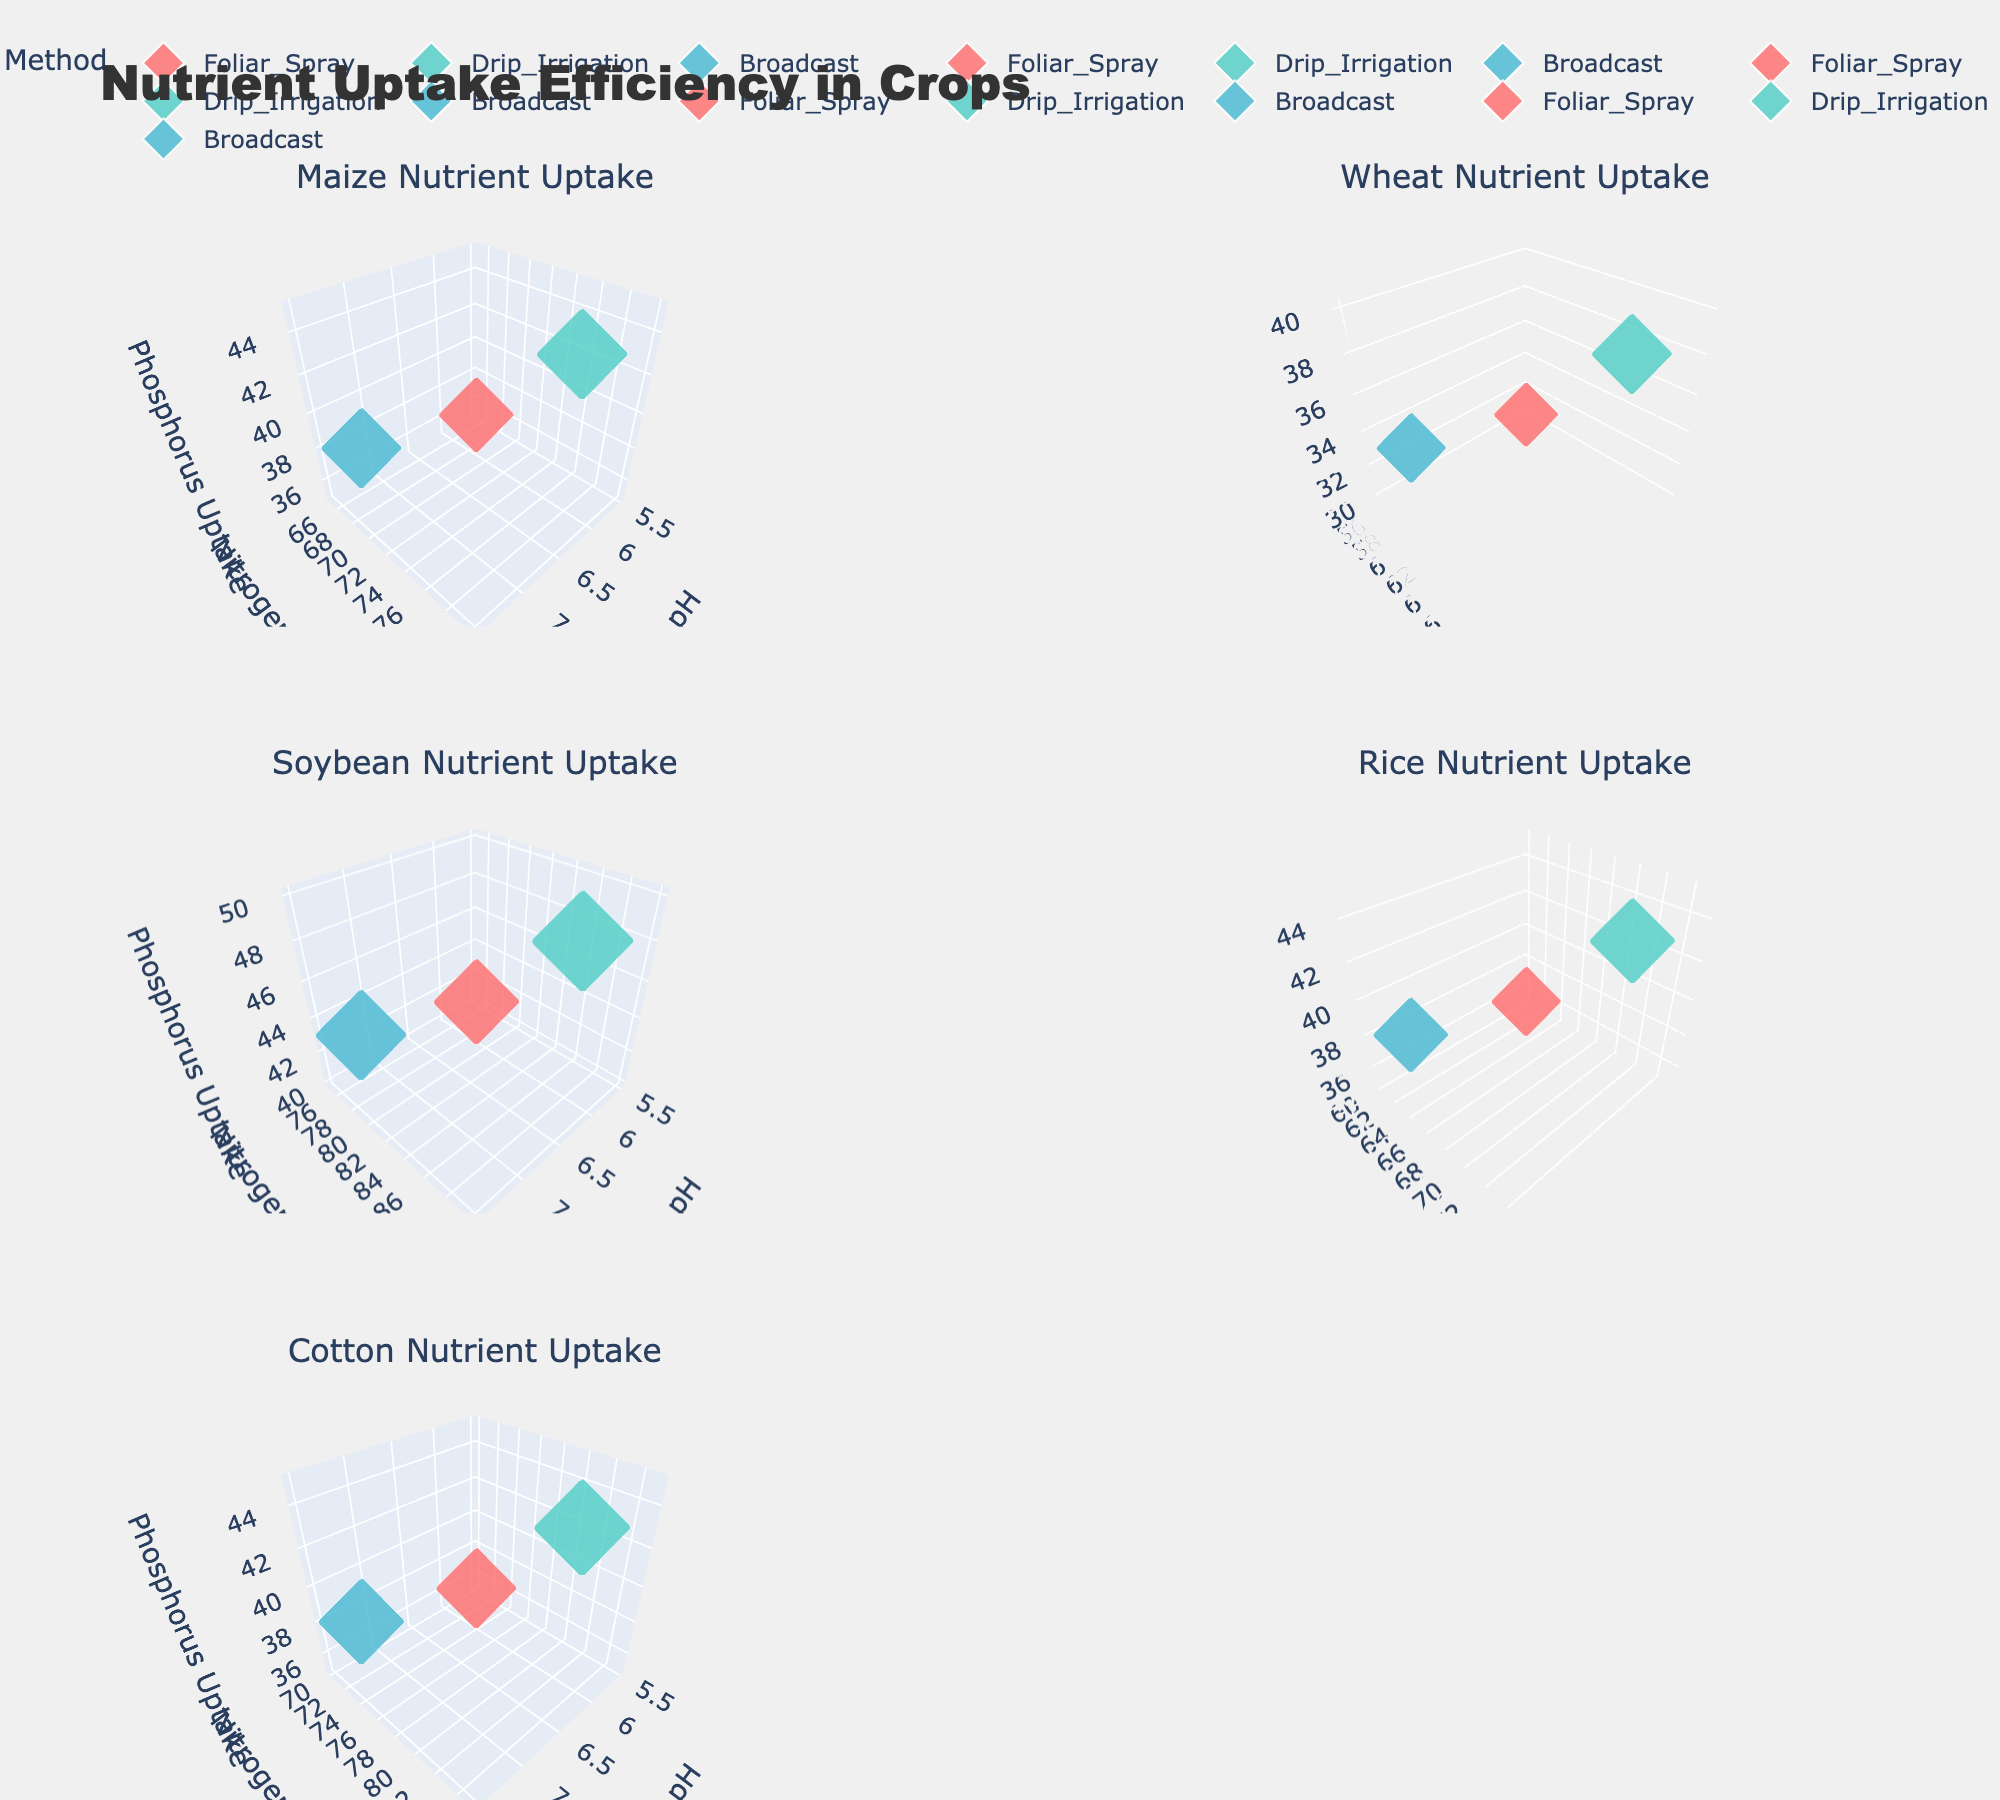what is the title of the figure? The title is located at the top of the figure.
Answer: Nutrient Uptake Efficiency in Crops How many crops are analyzed in the figure? Each subplot represents one crop and there are multiple subplots in the figure. Count the number of subplot titles.
Answer: 5 Which fertilizer method uses blue markers? Examine the color of the markers and note the corresponding legend entry.
Answer: Broadcast For Maize, what is the Soil pH value where Nitrogen Uptake is the highest? Focus on the Maize subplot and identify the data point with the highest Nitrogen Uptake, then check its Soil pH value from the hover text.
Answer: 6.5 In the Wheat subplot, how does Nitrogen Uptake for Drip Irrigation compare to Foliar Spray at pH 6.5? Locate the Wheat subplot, find the data points for Foliar Spray and Drip Irrigation at pH 6.5, and compare their Nitrogen Uptake values.
Answer: Drip Irrigation has higher Nitrogen Uptake Which crop and fertilization method combination results in the highest Potassium Uptake? Scan through each subplot to identify the data point with the highest Potassium Uptake by comparing the marker sizes.
Answer: Soybean with Drip Irrigation What is the general trend of nitrogen uptake with increasing soil pH for Cotton? Focus on the Cotton subplot and observe how Nitrogen Uptake values change as the Soil pH value increases from 5.5 to 7.5.
Answer: Increases with increasing pH In the Rice subplot, which fertilization method has the largest marker size at pH 6.5? Focus on the Rice subplot, identify the data point at pH 6.5, and compare the marker sizes among different fertilizer methods.
Answer: Drip Irrigation How does the Nitrogen Uptake of Soybean at pH 7.5 compare to that of Cotton at the same pH? Identify the Nitrogen Uptake value for Soybean and Cotton at pH 7.5 from their respective subplots, and compare them.
Answer: Soybean has higher Nitrogen Uptake For Wheat and Rice, which crop shows a larger increase in Phosphorus Uptake from Foliar Spray to Drip Irrigation at pH 5.5? Identify the Phosphorus Uptake values for Wheat and Rice at pH 5.5 using Foliar Spray and Drip Irrigation, calculate the increase for each crop, and compare them.
Answer: Rice shows a larger increase 